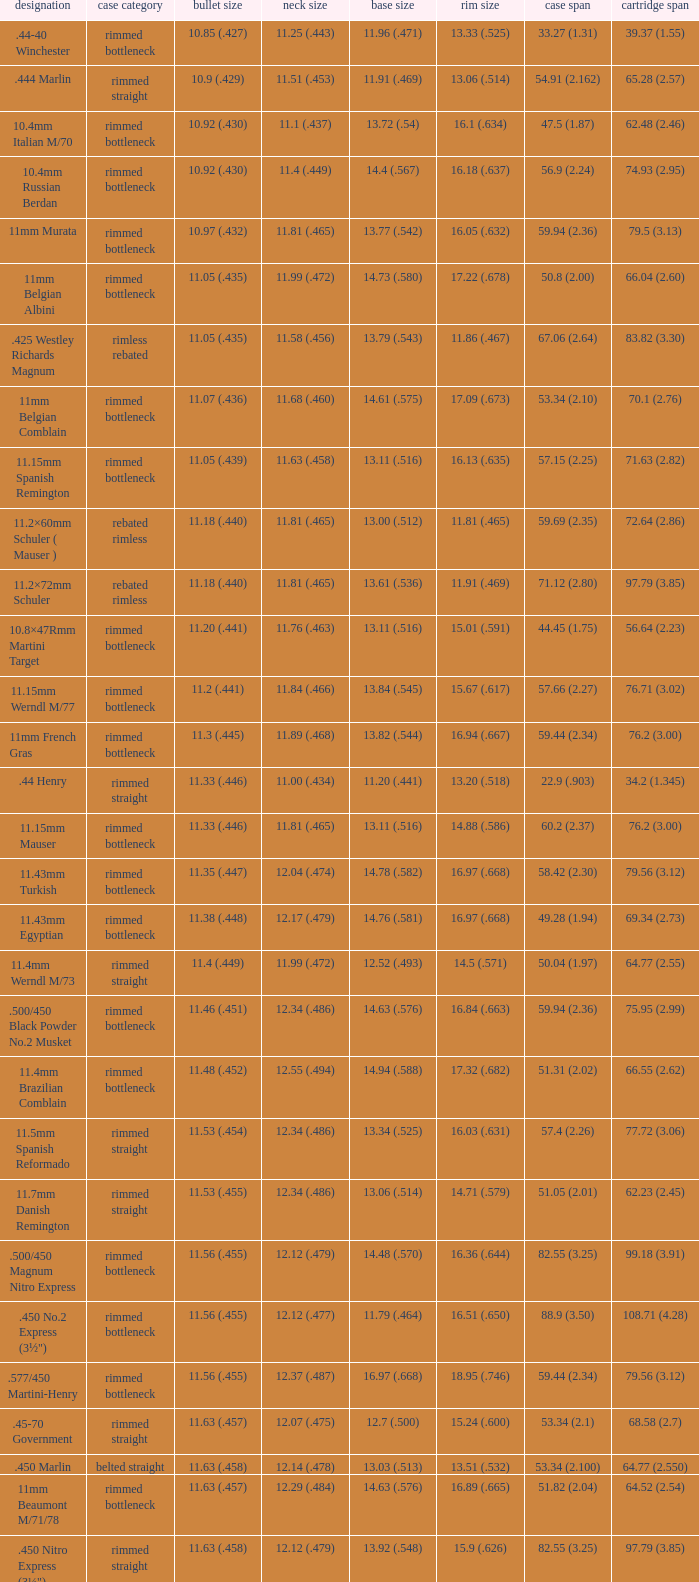Which Case type has a Cartridge length of 64.77 (2.550)? Belted straight. 